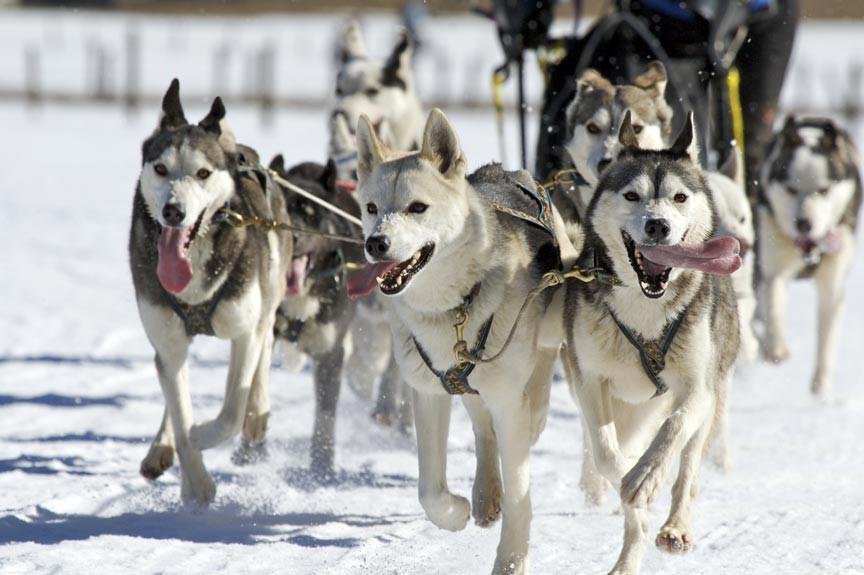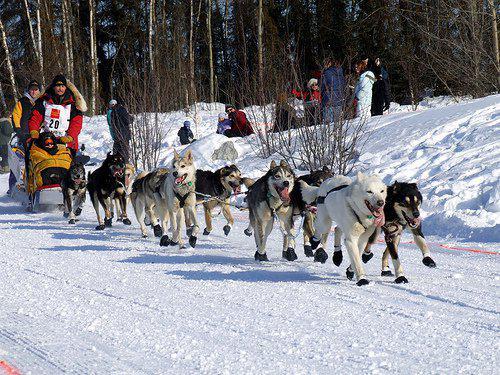The first image is the image on the left, the second image is the image on the right. Examine the images to the left and right. Is the description "An image shows a team of sled dogs wearing matching booties." accurate? Answer yes or no. Yes. The first image is the image on the left, the second image is the image on the right. Considering the images on both sides, is "There are at least three humans in the right image." valid? Answer yes or no. Yes. 